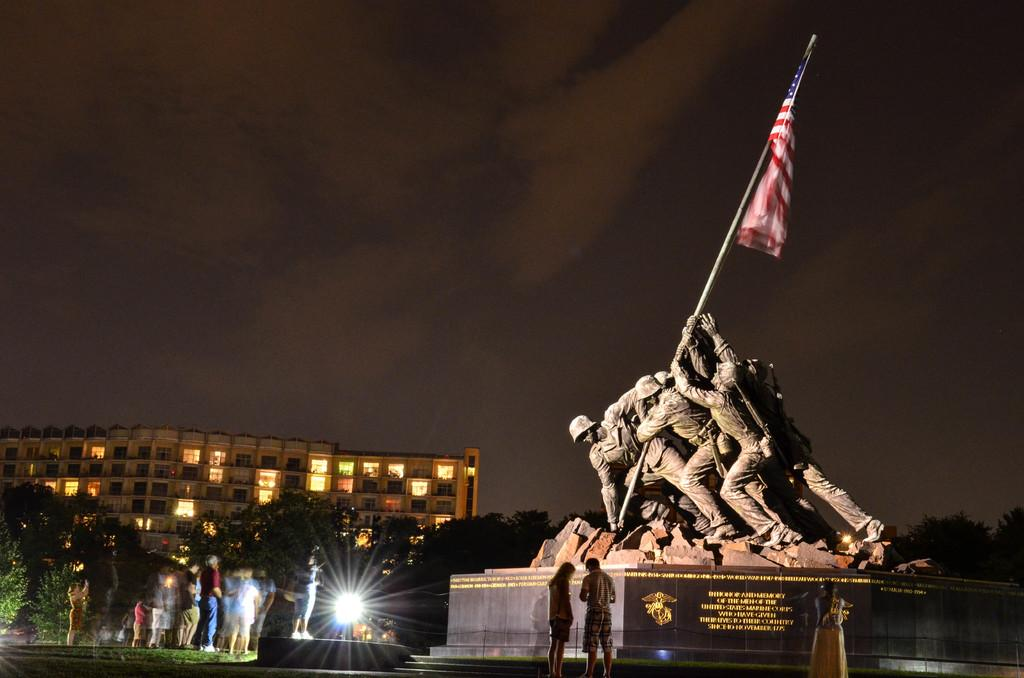What is the main subject in the image? There is a statue in the image. What can be seen on a wall in the image? There is text on a wall in the image. What is another object present in the image? There is a flag in the image. What is the position of the people in the image? There are people standing on the ground in the image. What type of vegetation is present in the image? There are trees in the image. What type of structure is visible in the image? There is a building with lights in the image. What is visible in the background of the image? The sky is visible in the background of the image. How many zinc pieces can be seen in the image? There is no mention of zinc pieces in the image, so it is not possible to determine their presence or quantity. 